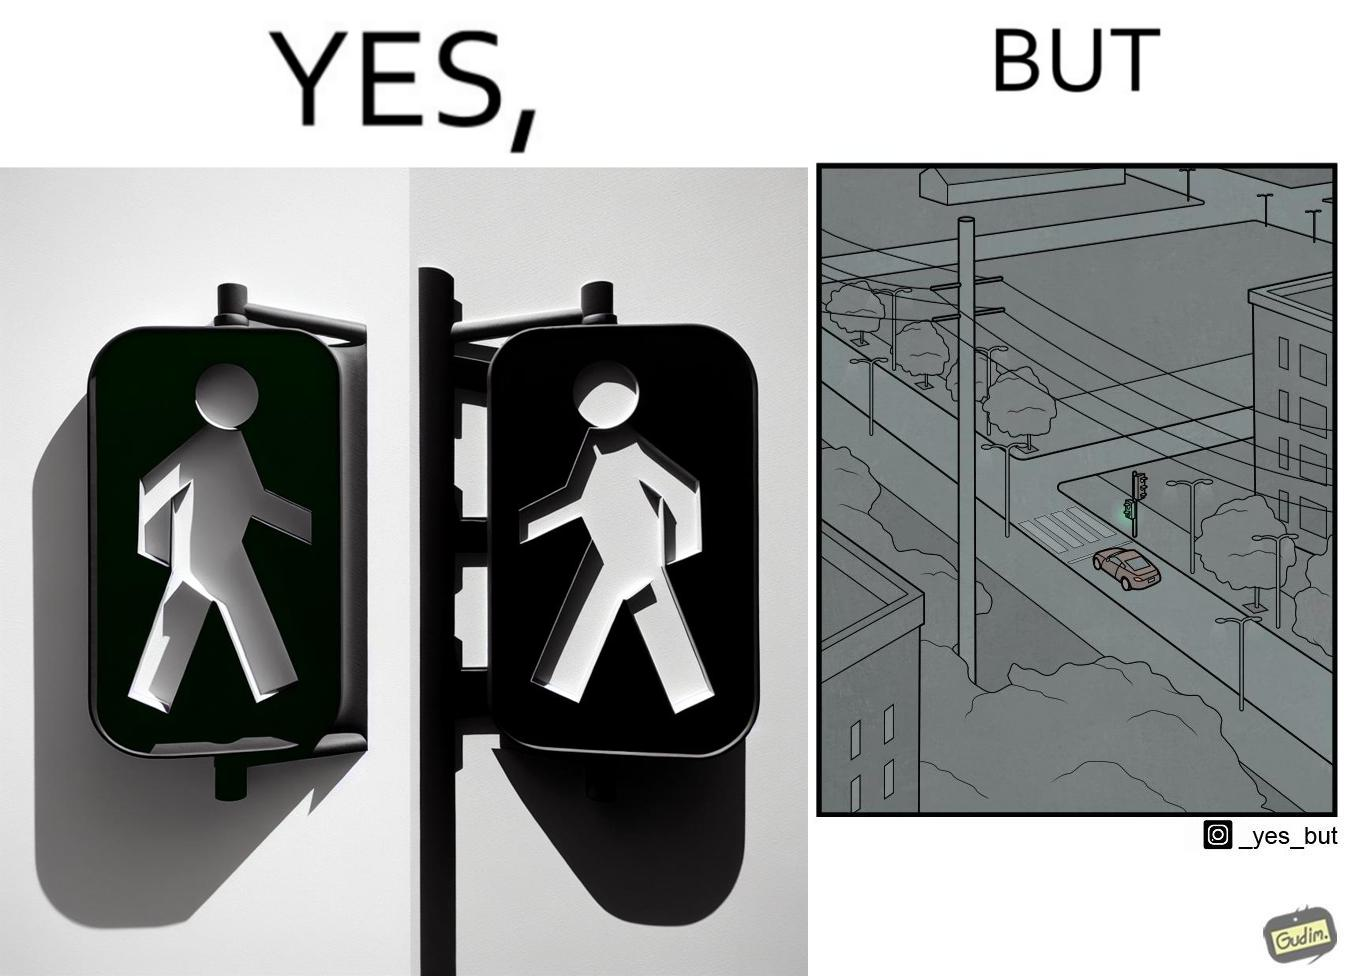What does this image depict? The image is funny because while walk signs are very useful for pedestrians to be able to cross roads safely, the become unnecessary and annoying for car drivers when these signals turn green even when there is no pedestrian tring to cross the road. 